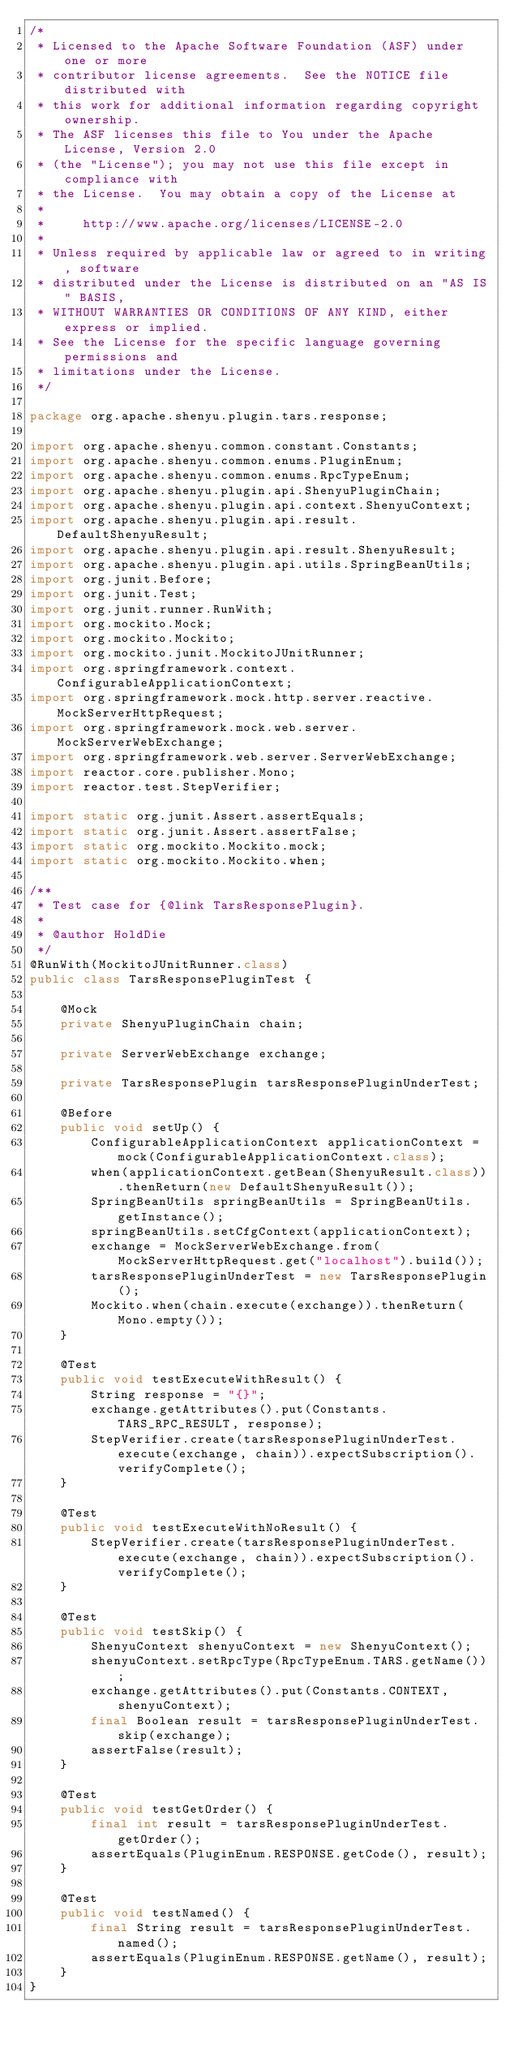<code> <loc_0><loc_0><loc_500><loc_500><_Java_>/*
 * Licensed to the Apache Software Foundation (ASF) under one or more
 * contributor license agreements.  See the NOTICE file distributed with
 * this work for additional information regarding copyright ownership.
 * The ASF licenses this file to You under the Apache License, Version 2.0
 * (the "License"); you may not use this file except in compliance with
 * the License.  You may obtain a copy of the License at
 *
 *     http://www.apache.org/licenses/LICENSE-2.0
 *
 * Unless required by applicable law or agreed to in writing, software
 * distributed under the License is distributed on an "AS IS" BASIS,
 * WITHOUT WARRANTIES OR CONDITIONS OF ANY KIND, either express or implied.
 * See the License for the specific language governing permissions and
 * limitations under the License.
 */

package org.apache.shenyu.plugin.tars.response;

import org.apache.shenyu.common.constant.Constants;
import org.apache.shenyu.common.enums.PluginEnum;
import org.apache.shenyu.common.enums.RpcTypeEnum;
import org.apache.shenyu.plugin.api.ShenyuPluginChain;
import org.apache.shenyu.plugin.api.context.ShenyuContext;
import org.apache.shenyu.plugin.api.result.DefaultShenyuResult;
import org.apache.shenyu.plugin.api.result.ShenyuResult;
import org.apache.shenyu.plugin.api.utils.SpringBeanUtils;
import org.junit.Before;
import org.junit.Test;
import org.junit.runner.RunWith;
import org.mockito.Mock;
import org.mockito.Mockito;
import org.mockito.junit.MockitoJUnitRunner;
import org.springframework.context.ConfigurableApplicationContext;
import org.springframework.mock.http.server.reactive.MockServerHttpRequest;
import org.springframework.mock.web.server.MockServerWebExchange;
import org.springframework.web.server.ServerWebExchange;
import reactor.core.publisher.Mono;
import reactor.test.StepVerifier;

import static org.junit.Assert.assertEquals;
import static org.junit.Assert.assertFalse;
import static org.mockito.Mockito.mock;
import static org.mockito.Mockito.when;

/**
 * Test case for {@link TarsResponsePlugin}.
 *
 * @author HoldDie
 */
@RunWith(MockitoJUnitRunner.class)
public class TarsResponsePluginTest {

    @Mock
    private ShenyuPluginChain chain;

    private ServerWebExchange exchange;

    private TarsResponsePlugin tarsResponsePluginUnderTest;

    @Before
    public void setUp() {
        ConfigurableApplicationContext applicationContext = mock(ConfigurableApplicationContext.class);
        when(applicationContext.getBean(ShenyuResult.class)).thenReturn(new DefaultShenyuResult());
        SpringBeanUtils springBeanUtils = SpringBeanUtils.getInstance();
        springBeanUtils.setCfgContext(applicationContext);
        exchange = MockServerWebExchange.from(MockServerHttpRequest.get("localhost").build());
        tarsResponsePluginUnderTest = new TarsResponsePlugin();
        Mockito.when(chain.execute(exchange)).thenReturn(Mono.empty());
    }

    @Test
    public void testExecuteWithResult() {
        String response = "{}";
        exchange.getAttributes().put(Constants.TARS_RPC_RESULT, response);
        StepVerifier.create(tarsResponsePluginUnderTest.execute(exchange, chain)).expectSubscription().verifyComplete();
    }

    @Test
    public void testExecuteWithNoResult() {
        StepVerifier.create(tarsResponsePluginUnderTest.execute(exchange, chain)).expectSubscription().verifyComplete();
    }

    @Test
    public void testSkip() {
        ShenyuContext shenyuContext = new ShenyuContext();
        shenyuContext.setRpcType(RpcTypeEnum.TARS.getName());
        exchange.getAttributes().put(Constants.CONTEXT, shenyuContext);
        final Boolean result = tarsResponsePluginUnderTest.skip(exchange);
        assertFalse(result);
    }

    @Test
    public void testGetOrder() {
        final int result = tarsResponsePluginUnderTest.getOrder();
        assertEquals(PluginEnum.RESPONSE.getCode(), result);
    }

    @Test
    public void testNamed() {
        final String result = tarsResponsePluginUnderTest.named();
        assertEquals(PluginEnum.RESPONSE.getName(), result);
    }
}
</code> 